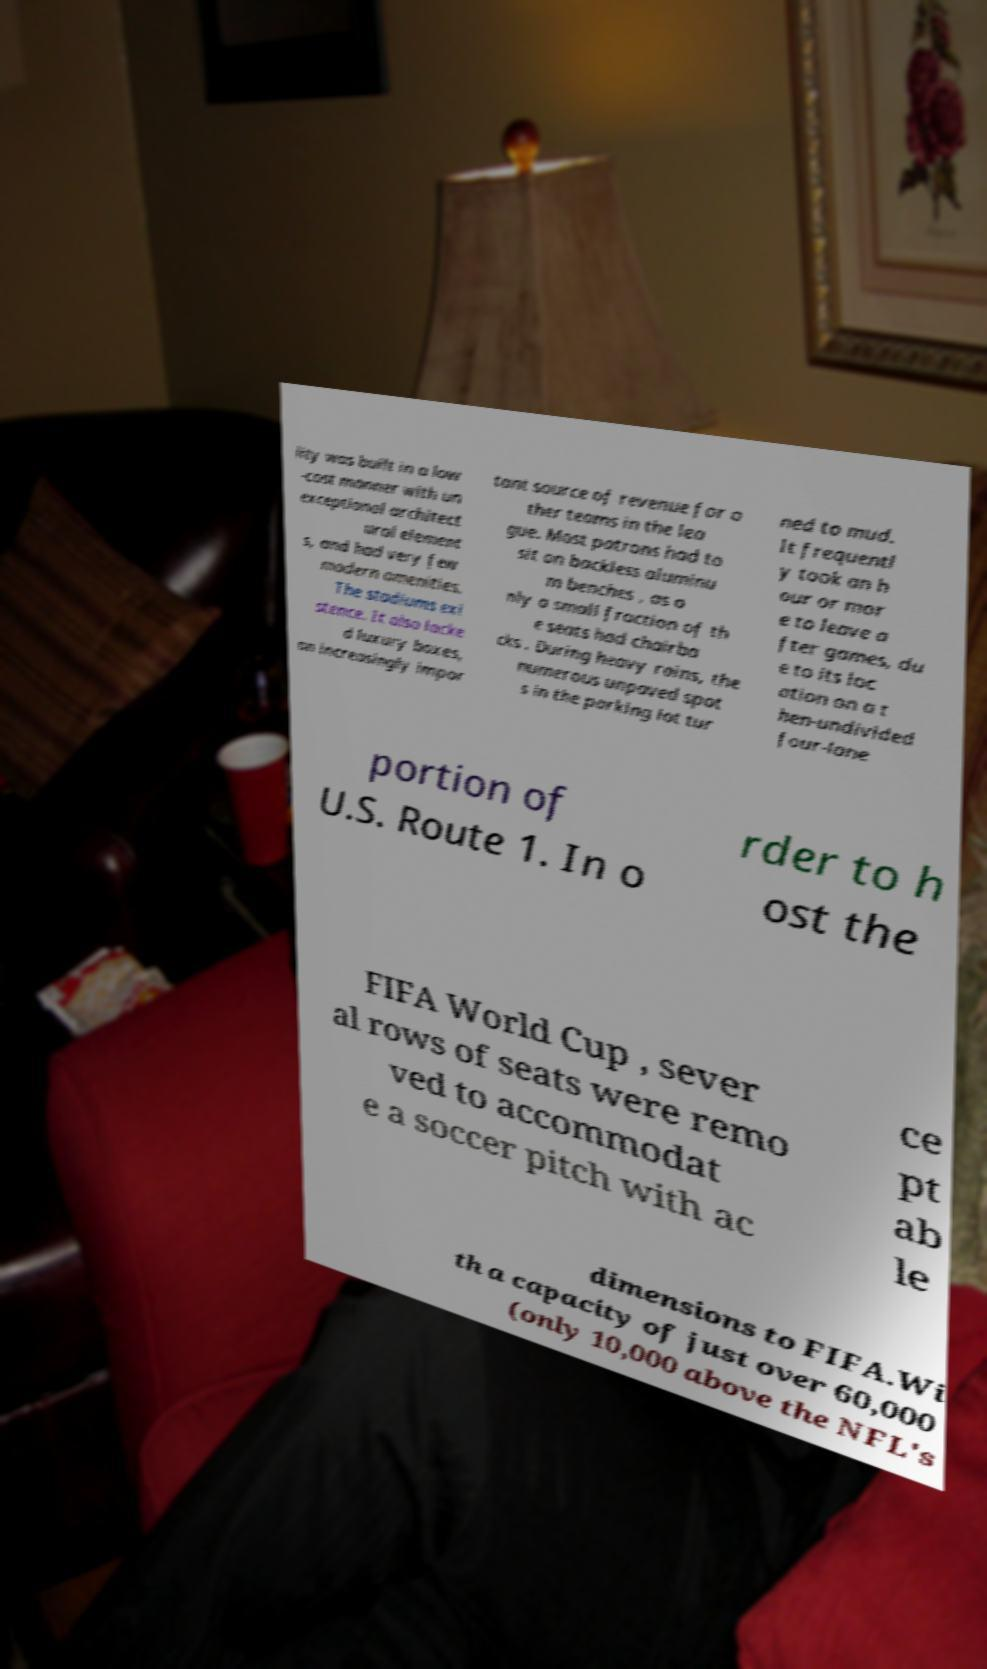I need the written content from this picture converted into text. Can you do that? lity was built in a low -cost manner with un exceptional architect ural element s, and had very few modern amenities. The stadiums exi stence. It also lacke d luxury boxes, an increasingly impor tant source of revenue for o ther teams in the lea gue. Most patrons had to sit on backless aluminu m benches , as o nly a small fraction of th e seats had chairba cks . During heavy rains, the numerous unpaved spot s in the parking lot tur ned to mud. It frequentl y took an h our or mor e to leave a fter games, du e to its loc ation on a t hen-undivided four-lane portion of U.S. Route 1. In o rder to h ost the FIFA World Cup , sever al rows of seats were remo ved to accommodat e a soccer pitch with ac ce pt ab le dimensions to FIFA.Wi th a capacity of just over 60,000 (only 10,000 above the NFL's 